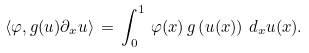<formula> <loc_0><loc_0><loc_500><loc_500>\langle \varphi , g ( u ) \partial _ { x } u \rangle \, = \, \int _ { 0 } ^ { 1 } \, \varphi ( x ) \, g \left ( u ( x ) \right ) \, d _ { x } u ( x ) .</formula> 